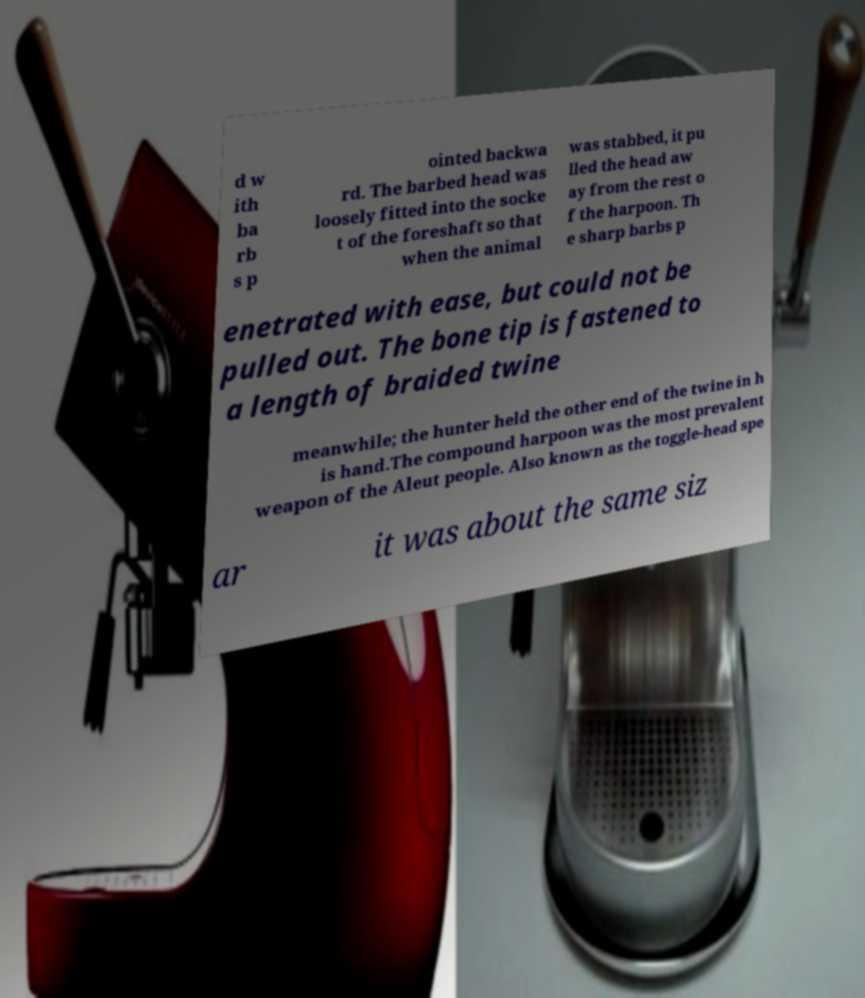For documentation purposes, I need the text within this image transcribed. Could you provide that? d w ith ba rb s p ointed backwa rd. The barbed head was loosely fitted into the socke t of the foreshaft so that when the animal was stabbed, it pu lled the head aw ay from the rest o f the harpoon. Th e sharp barbs p enetrated with ease, but could not be pulled out. The bone tip is fastened to a length of braided twine meanwhile; the hunter held the other end of the twine in h is hand.The compound harpoon was the most prevalent weapon of the Aleut people. Also known as the toggle-head spe ar it was about the same siz 